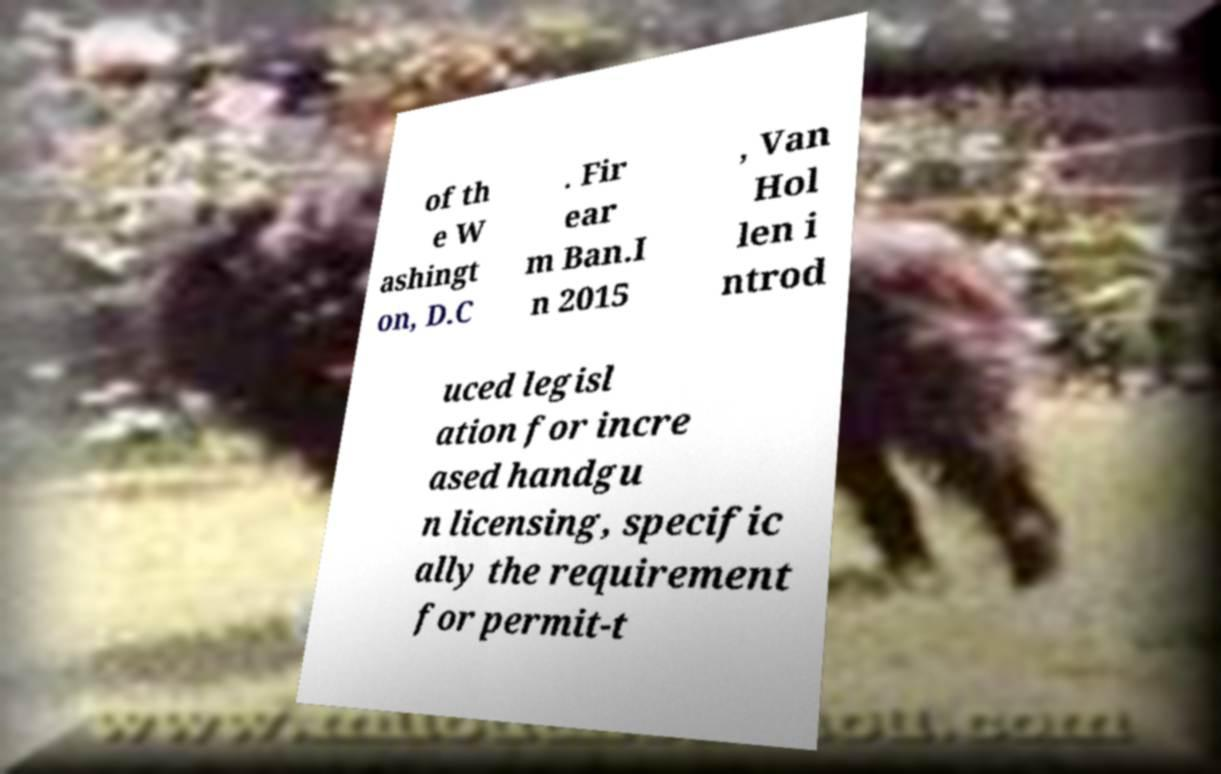What messages or text are displayed in this image? I need them in a readable, typed format. of th e W ashingt on, D.C . Fir ear m Ban.I n 2015 , Van Hol len i ntrod uced legisl ation for incre ased handgu n licensing, specific ally the requirement for permit-t 